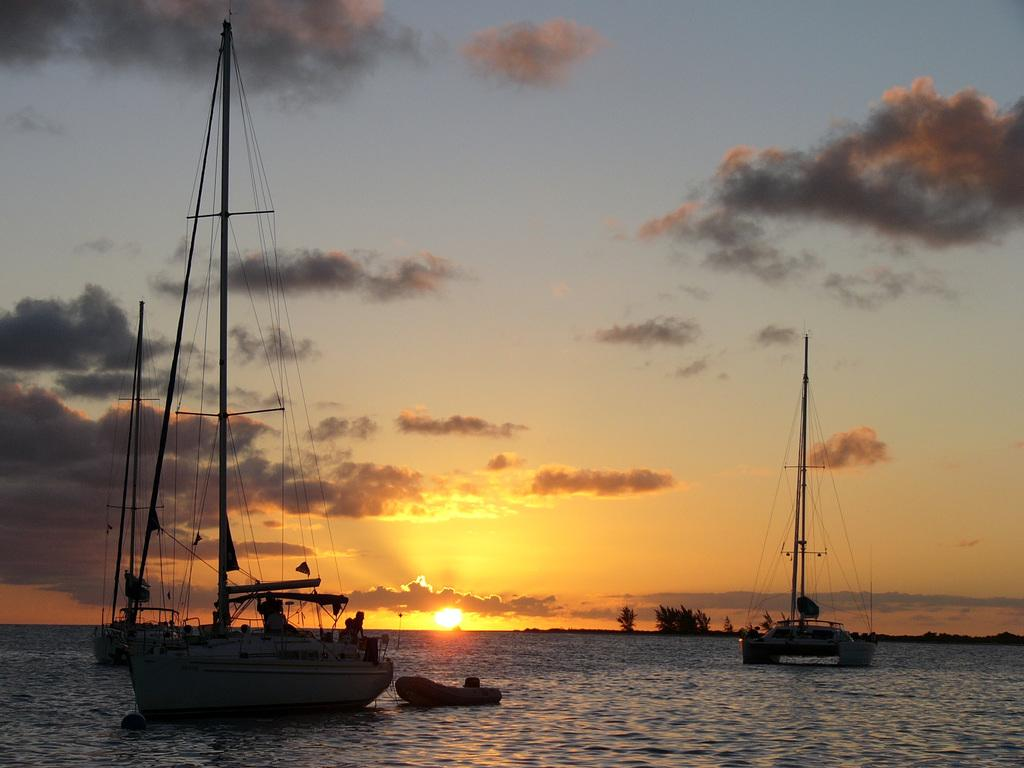What type of vehicles can be seen on the surface of the sea in the image? There are ships on the surface of the sea in the image. What is the color of the sky in the image? The sky is blue in color. What can be seen in the sky besides the blue color? There are clouds in the sky. What celestial body is visible in the sky? The sun is visible in the sky. What type of holiday is being celebrated by the ships in the image? There is no indication of a holiday being celebrated in the image; it simply shows ships on the sea. What record is being set by the clouds in the image? There is no record being set by the clouds in the image; they are simply present in the sky. 